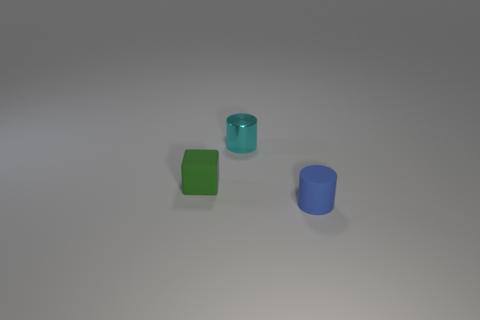Is there any other thing that has the same material as the tiny cyan thing?
Your response must be concise. No. How many rubber objects are either green blocks or cylinders?
Provide a short and direct response. 2. Are there any blue matte cylinders on the left side of the matte object that is left of the small cyan metallic cylinder?
Provide a succinct answer. No. What number of cubes are on the right side of the tiny metal object?
Provide a succinct answer. 0. The other tiny matte object that is the same shape as the small cyan thing is what color?
Provide a succinct answer. Blue. Do the thing that is on the left side of the cyan cylinder and the small object behind the green matte block have the same material?
Keep it short and to the point. No. There is a tiny object that is both in front of the cyan metal cylinder and right of the tiny green block; what is its shape?
Make the answer very short. Cylinder. What number of big green metal cubes are there?
Offer a terse response. 0. There is another object that is the same shape as the small cyan metallic thing; what size is it?
Your answer should be compact. Small. There is a rubber object that is in front of the green block; does it have the same shape as the tiny green object?
Offer a terse response. No. 